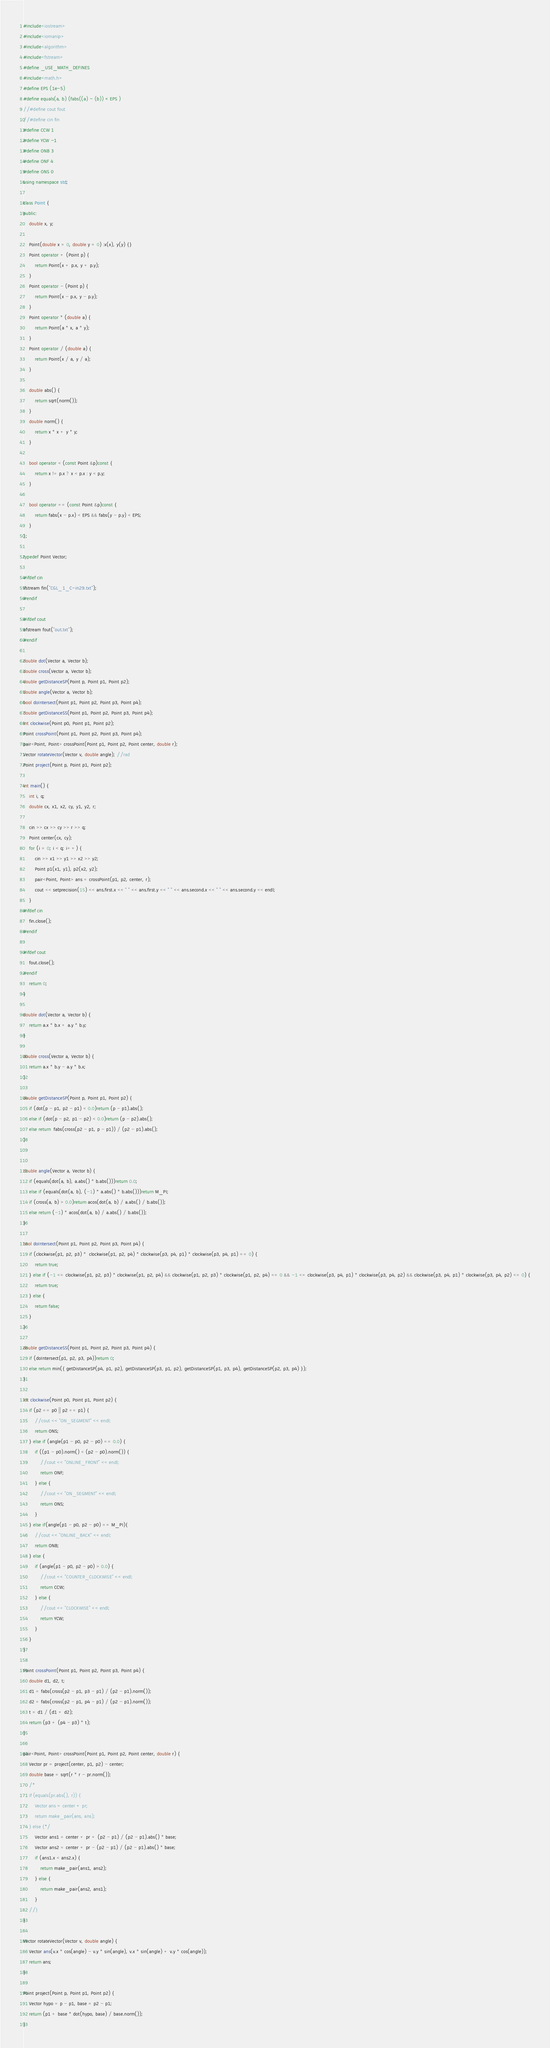<code> <loc_0><loc_0><loc_500><loc_500><_C++_>#include<iostream>
#include<iomanip>
#include<algorithm>
#include<fstream>
#define _USE_MATH_DEFINES
#include<math.h>
#define EPS (1e-5)
#define equals(a, b) (fabs((a) - (b)) < EPS )
//#define cout fout
//#define cin fin
#define CCW 1
#define YCW -1
#define ONB 3
#define ONF 4
#define ONS 0
using namespace std;

class Point {
public:
	double x, y;

	Point(double x = 0, double y = 0) :x(x), y(y) {}
	Point operator + (Point p) {
		return Point(x + p.x, y + p.y); 
	}
	Point operator - (Point p) {
		return Point(x - p.x, y - p.y);
	}
	Point operator * (double a) {
		return Point(a * x, a * y);
	}
	Point operator / (double a) {
		return Point(x / a, y / a);
	}

	double abs() {
		return sqrt(norm());
	}
	double norm() {
		return x * x + y * y;
	}

	bool operator < (const Point &p)const {
		return x != p.x ? x < p.x : y < p.y;
	}

	bool operator == (const Point &p)const {
		return fabs(x - p.x) < EPS && fabs(y - p.y) < EPS;
	}
};

typedef Point Vector;

#ifdef cin
ifstream fin("CGL_1_C-in29.txt");
#endif

#ifdef cout
ofstream fout("out.txt");
#endif

double dot(Vector a, Vector b);
double cross(Vector a, Vector b);
double getDistanceSP(Point p, Point p1, Point p2);
double angle(Vector a, Vector b);
bool doIntersect(Point p1, Point p2, Point p3, Point p4);
double getDistanceSS(Point p1, Point p2, Point p3, Point p4);
int clockwise(Point p0, Point p1, Point p2);
Point crossPoint(Point p1, Point p2, Point p3, Point p4);
pair<Point, Point> crossPoint(Point p1, Point p2, Point center, double r);
Vector rotateVector(Vector v, double angle); //rad
Point project(Point p, Point p1, Point p2);

int main() {
    int i, q;
	double cx, x1, x2, cy, y1, y2, r;
	
	cin >> cx >> cy >> r >> q;
	Point center(cx, cy);
	for (i = 0; i < q; i++) {
		cin >> x1 >> y1 >> x2 >> y2;
		Point p1(x1, y1), p2(x2, y2);
		pair<Point, Point> ans = crossPoint(p1, p2, center, r);
		cout << setprecision(15) << ans.first.x << " " << ans.first.y << " " << ans.second.x << " " << ans.second.y << endl;
	}
#ifdef cin
	fin.close();
#endif

#ifdef cout
	fout.close();
#endif
	return 0;
}

double dot(Vector a, Vector b) {
	return a.x * b.x + a.y * b.y;
}

double cross(Vector a, Vector b) {
	return a.x * b.y - a.y * b.x;
}

double getDistanceSP(Point p, Point p1, Point p2) {
	if (dot(p - p1, p2 - p1) < 0.0)return (p - p1).abs();
	else if (dot(p - p2, p1 - p2) < 0.0)return (p - p2).abs();
	else return  fabs(cross(p2 - p1, p - p1)) / (p2 - p1).abs();
}


double angle(Vector a, Vector b) {
	if (equals(dot(a, b), a.abs() * b.abs()))return 0.0;
	else if (equals(dot(a, b), (-1) * a.abs() * b.abs()))return M_PI;
	if (cross(a, b) > 0.0)return acos(dot(a, b) / a.abs() / b.abs());
	else return (-1) * acos(dot(a, b) / a.abs() / b.abs());
}

bool doIntersect(Point p1, Point p2, Point p3, Point p4) {
	if (clockwise(p1, p2, p3) *  clockwise(p1, p2, p4) * clockwise(p3, p4, p1) * clockwise(p3, p4, p1) == 0) {
		return true;
	} else if (-1 <= clockwise(p1, p2, p3) * clockwise(p1, p2, p4) && clockwise(p1, p2, p3) * clockwise(p1, p2, p4) <= 0 && -1 <= clockwise(p3, p4, p1) * clockwise(p3, p4, p2) && clockwise(p3, p4, p1) * clockwise(p3, p4, p2) <= 0) {
		return true;
	} else {
		return false;
	}
}

double getDistanceSS(Point p1, Point p2, Point p3, Point p4) {
	if (doIntersect(p1, p2, p3, p4))return 0;
	else return min({ getDistanceSP(p4, p1, p2), getDistanceSP(p3, p1, p2), getDistanceSP(p1, p3, p4), getDistanceSP(p2, p3, p4) });
}

int clockwise(Point p0, Point p1, Point p2) {
	if (p2 == p0 || p2 == p1) {
		//cout << "ON_SEGMENT" << endl;
		return ONS;
	} else if (angle(p1 - p0, p2 - p0) == 0.0) {
		if ((p1 - p0).norm() < (p2 - p0).norm()) {
			//cout << "ONLINE_FRONT" << endl;
			return ONF;
		} else {
			//cout << "ON_SEGMENT" << endl;
			return ONS;
		}
	} else if(angle(p1 - p0, p2 - p0) == M_PI){
		//cout << "ONLINE_BACK" << endl;
		return ONB;
	} else {
		if (angle(p1 - p0, p2 - p0) > 0.0) {
			//cout << "COUNTER_CLOCKWISE" << endl;
			return CCW;
		} else {
			//cout << "CLOCKWISE" << endl;
			return YCW;
		}
	}
}

Point crossPoint(Point p1, Point p2, Point p3, Point p4) {
	double d1, d2, t;
	d1 = fabs(cross(p2 - p1, p3 - p1) / (p2 - p1).norm());
	d2 = fabs(cross(p2 - p1, p4 - p1) / (p2 - p1).norm());
	t = d1 / (d1 + d2);
	return (p3 + (p4 - p3) * t);
}

pair<Point, Point> crossPoint(Point p1, Point p2, Point center, double r) {
	Vector pr = project(center, p1, p2) - center;
	double base = sqrt(r * r - pr.norm());
	/*
	if (equals(pr.abs(), r)) {
		Vector ans = center + pr;
		return make_pair(ans, ans);
	} else {*/
		Vector ans1 = center + pr + (p2 - p1) / (p2 - p1).abs() * base;
		Vector ans2 = center + pr - (p2 - p1) / (p2 - p1).abs() * base;
		if (ans1.x < ans2.x) {
			return make_pair(ans1, ans2);
		} else {
			return make_pair(ans2, ans1);
		}
	//}
}

Vector rotateVector(Vector v, double angle) {
	Vector ans(v.x * cos(angle) - v.y * sin(angle), v.x * sin(angle) + v.y * cos(angle));
	return ans;
}

Point project(Point p, Point p1, Point p2) {
	Vector hypo = p - p1, base = p2 - p1;
	return (p1 + base * dot(hypo, base) / base.norm());
}</code> 